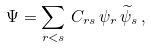Convert formula to latex. <formula><loc_0><loc_0><loc_500><loc_500>\Psi = \sum _ { r < s } \, C _ { r s } \, \psi _ { r } \, \widetilde { \psi } _ { s } \, ,</formula> 